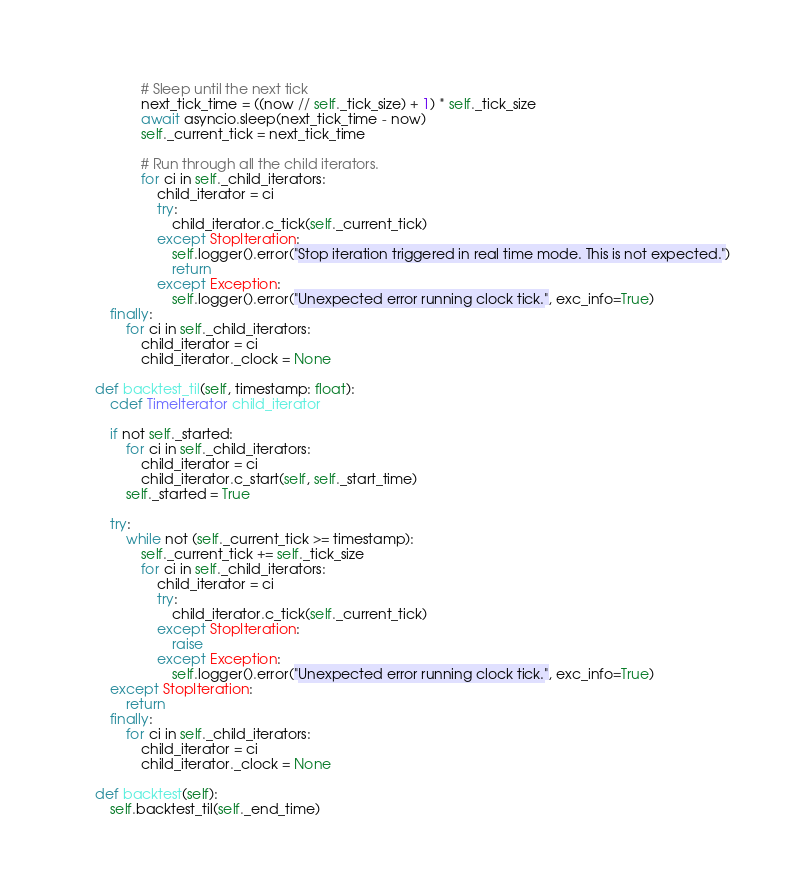Convert code to text. <code><loc_0><loc_0><loc_500><loc_500><_Cython_>
                # Sleep until the next tick
                next_tick_time = ((now // self._tick_size) + 1) * self._tick_size
                await asyncio.sleep(next_tick_time - now)
                self._current_tick = next_tick_time

                # Run through all the child iterators.
                for ci in self._child_iterators:
                    child_iterator = ci
                    try:
                        child_iterator.c_tick(self._current_tick)
                    except StopIteration:
                        self.logger().error("Stop iteration triggered in real time mode. This is not expected.")
                        return
                    except Exception:
                        self.logger().error("Unexpected error running clock tick.", exc_info=True)
        finally:
            for ci in self._child_iterators:
                child_iterator = ci
                child_iterator._clock = None

    def backtest_til(self, timestamp: float):
        cdef TimeIterator child_iterator

        if not self._started:
            for ci in self._child_iterators:
                child_iterator = ci
                child_iterator.c_start(self, self._start_time)
            self._started = True

        try:
            while not (self._current_tick >= timestamp):
                self._current_tick += self._tick_size
                for ci in self._child_iterators:
                    child_iterator = ci
                    try:
                        child_iterator.c_tick(self._current_tick)
                    except StopIteration:
                        raise
                    except Exception:
                        self.logger().error("Unexpected error running clock tick.", exc_info=True)
        except StopIteration:
            return
        finally:
            for ci in self._child_iterators:
                child_iterator = ci
                child_iterator._clock = None

    def backtest(self):
        self.backtest_til(self._end_time)

</code> 